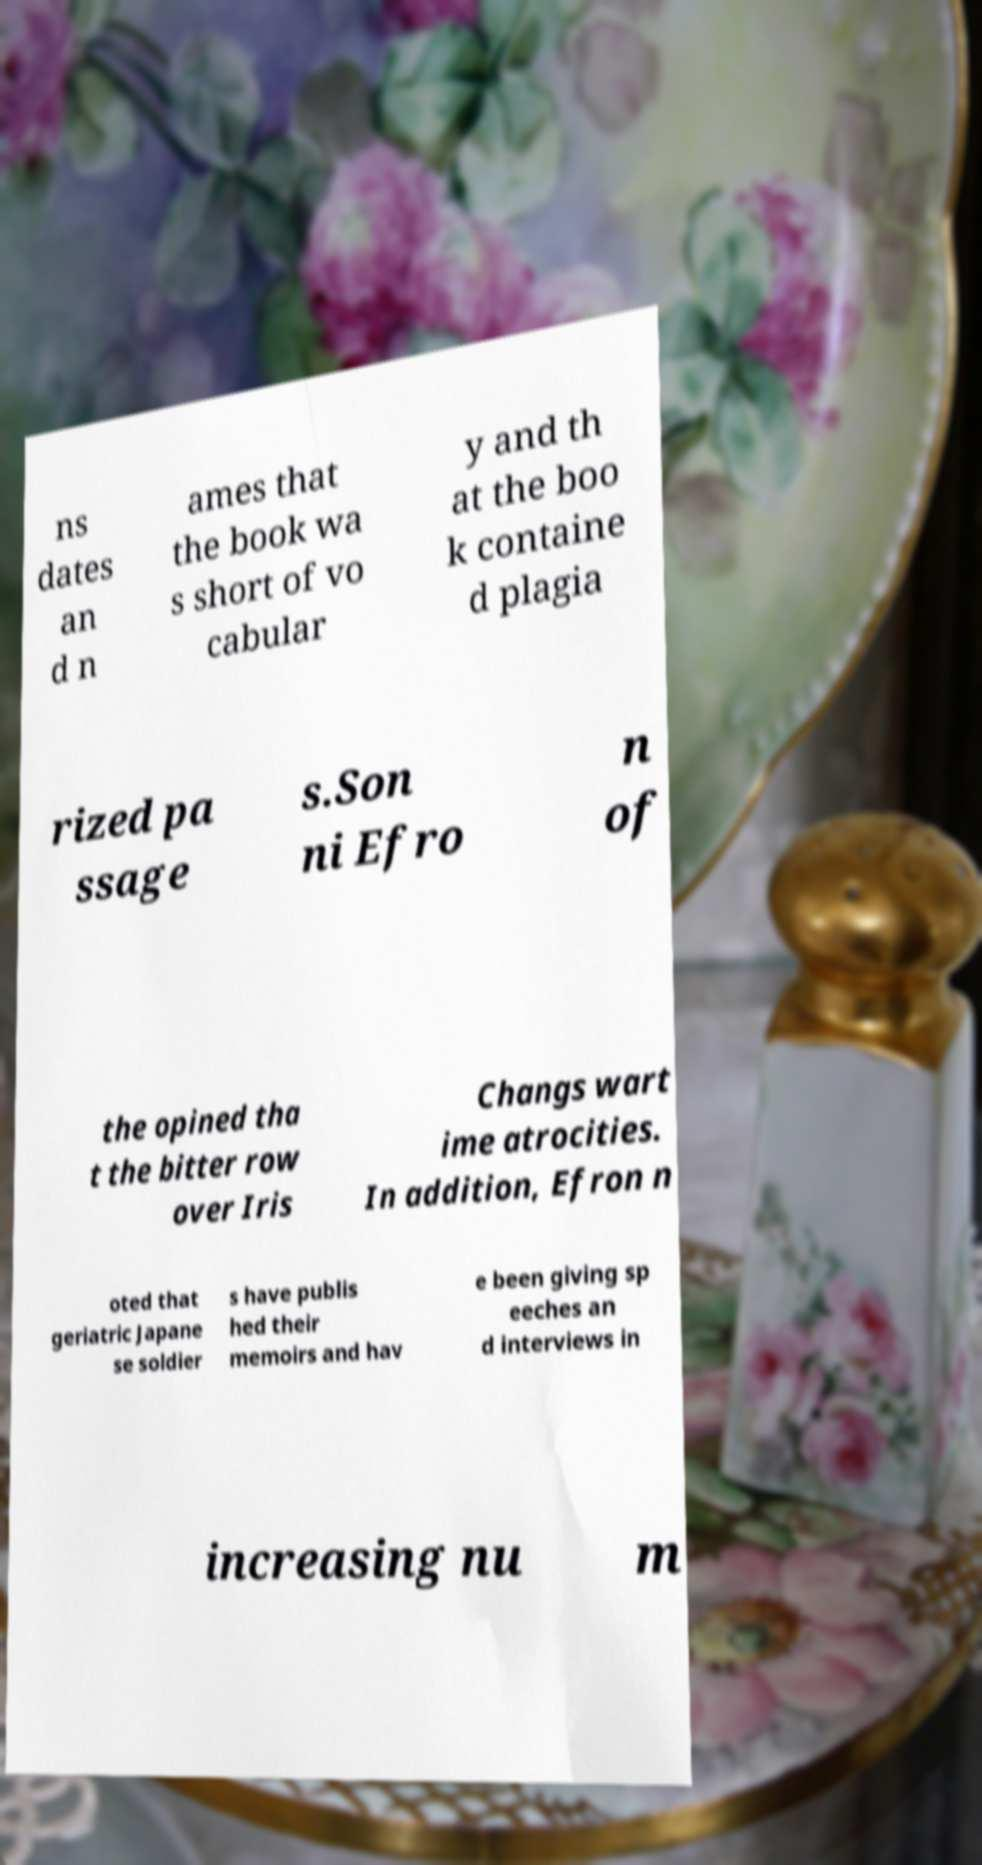Please identify and transcribe the text found in this image. ns dates an d n ames that the book wa s short of vo cabular y and th at the boo k containe d plagia rized pa ssage s.Son ni Efro n of the opined tha t the bitter row over Iris Changs wart ime atrocities. In addition, Efron n oted that geriatric Japane se soldier s have publis hed their memoirs and hav e been giving sp eeches an d interviews in increasing nu m 